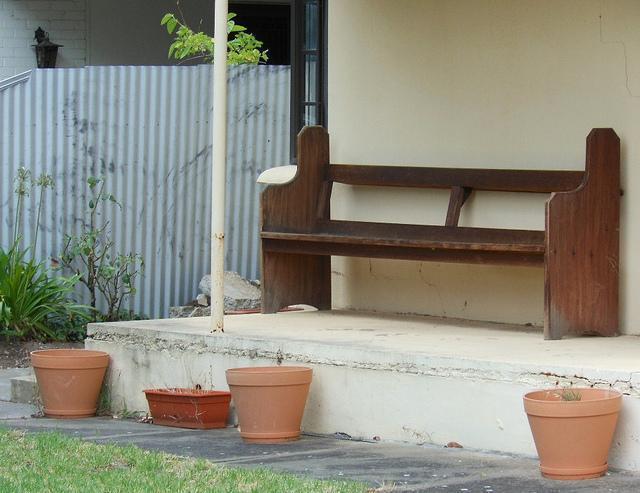What element is needed for the contents of the pots to extend their lives?
Choose the correct response, then elucidate: 'Answer: answer
Rationale: rationale.'
Options: Cement, water, milk, juice. Answer: water.
Rationale: Plants need to be watered to live and grow 